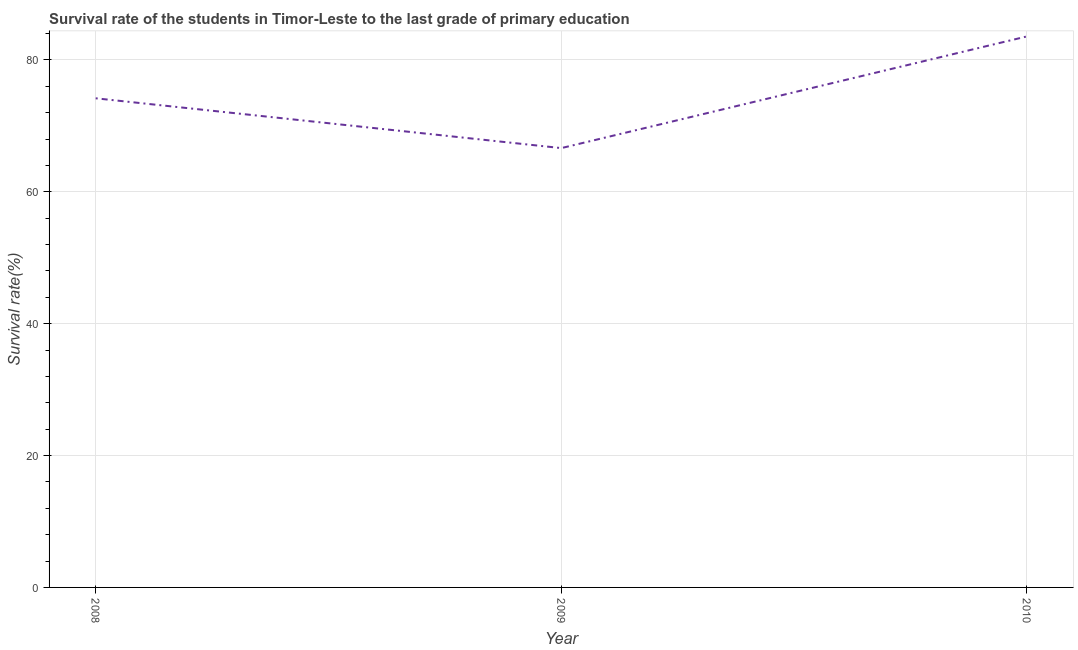What is the survival rate in primary education in 2010?
Offer a terse response. 83.56. Across all years, what is the maximum survival rate in primary education?
Your answer should be very brief. 83.56. Across all years, what is the minimum survival rate in primary education?
Your answer should be very brief. 66.62. In which year was the survival rate in primary education maximum?
Provide a short and direct response. 2010. What is the sum of the survival rate in primary education?
Offer a very short reply. 224.36. What is the difference between the survival rate in primary education in 2009 and 2010?
Offer a very short reply. -16.94. What is the average survival rate in primary education per year?
Your response must be concise. 74.79. What is the median survival rate in primary education?
Ensure brevity in your answer.  74.17. In how many years, is the survival rate in primary education greater than 56 %?
Make the answer very short. 3. What is the ratio of the survival rate in primary education in 2008 to that in 2010?
Ensure brevity in your answer.  0.89. What is the difference between the highest and the second highest survival rate in primary education?
Offer a very short reply. 9.38. Is the sum of the survival rate in primary education in 2009 and 2010 greater than the maximum survival rate in primary education across all years?
Provide a short and direct response. Yes. What is the difference between the highest and the lowest survival rate in primary education?
Offer a terse response. 16.94. How many lines are there?
Your answer should be compact. 1. What is the title of the graph?
Your answer should be very brief. Survival rate of the students in Timor-Leste to the last grade of primary education. What is the label or title of the X-axis?
Ensure brevity in your answer.  Year. What is the label or title of the Y-axis?
Ensure brevity in your answer.  Survival rate(%). What is the Survival rate(%) of 2008?
Provide a succinct answer. 74.17. What is the Survival rate(%) in 2009?
Provide a short and direct response. 66.62. What is the Survival rate(%) of 2010?
Provide a short and direct response. 83.56. What is the difference between the Survival rate(%) in 2008 and 2009?
Your answer should be compact. 7.55. What is the difference between the Survival rate(%) in 2008 and 2010?
Keep it short and to the point. -9.38. What is the difference between the Survival rate(%) in 2009 and 2010?
Your response must be concise. -16.94. What is the ratio of the Survival rate(%) in 2008 to that in 2009?
Ensure brevity in your answer.  1.11. What is the ratio of the Survival rate(%) in 2008 to that in 2010?
Keep it short and to the point. 0.89. What is the ratio of the Survival rate(%) in 2009 to that in 2010?
Make the answer very short. 0.8. 